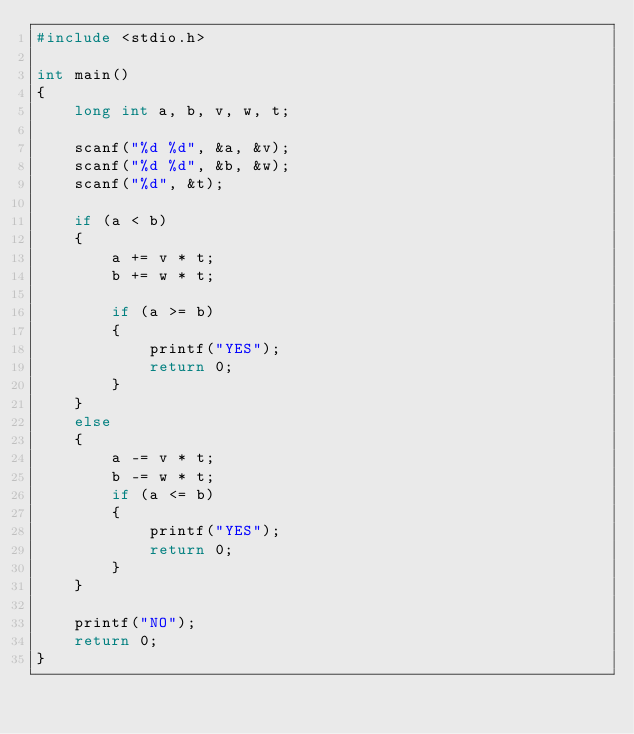Convert code to text. <code><loc_0><loc_0><loc_500><loc_500><_C_>#include <stdio.h>

int main()
{
    long int a, b, v, w, t;

    scanf("%d %d", &a, &v);
    scanf("%d %d", &b, &w);
    scanf("%d", &t);

    if (a < b)
    {
        a += v * t;
        b += w * t;

        if (a >= b)
        {
            printf("YES");
            return 0;
        }
    }
    else
    {
        a -= v * t;
        b -= w * t;
        if (a <= b)
        {
            printf("YES");
            return 0;
        }
    }

    printf("NO");
    return 0;
}
</code> 